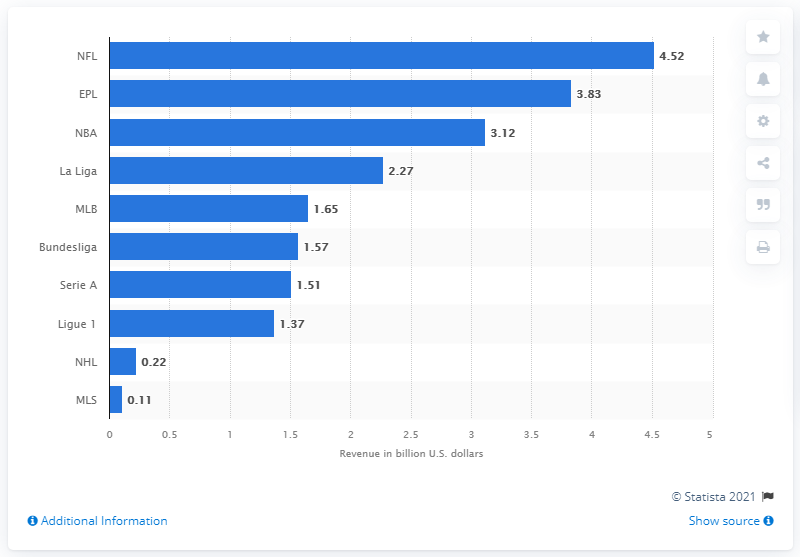Specify some key components in this picture. The NFL generated approximately 4.52 billion U.S. dollars in broadcasting rights worldwide in 2019. 